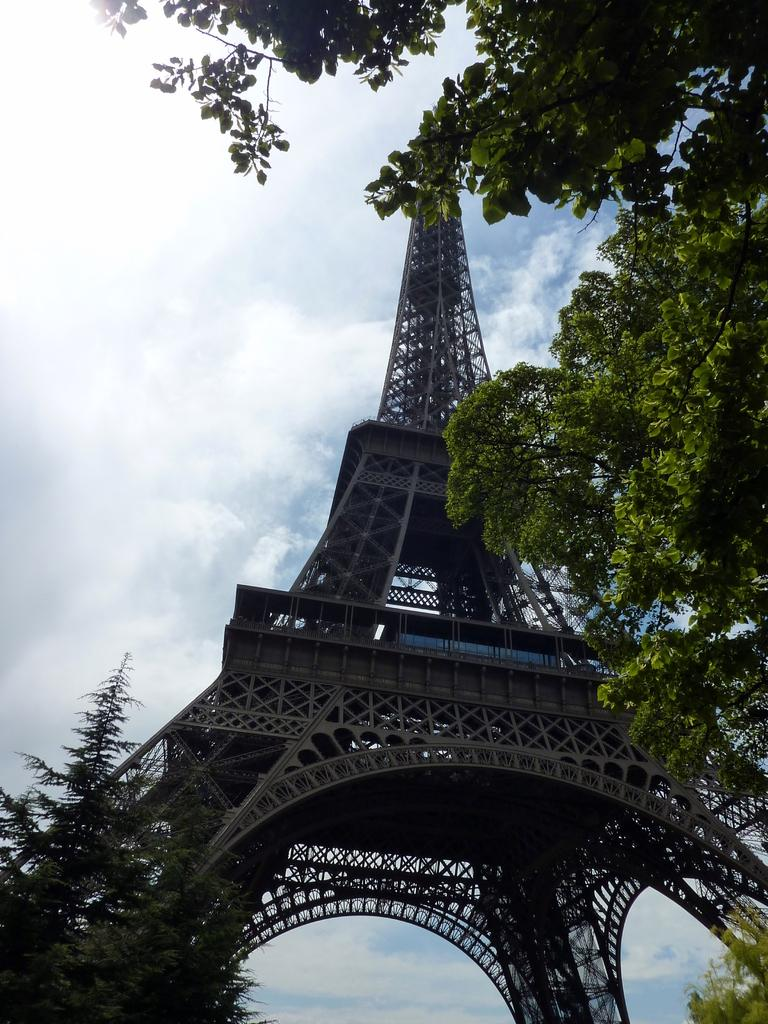What famous landmark can be seen in the image? The Eiffel Tower is visible in the image. What type of vegetation is present in the image? There are branches of trees in the image. What can be seen in the background of the image? The sky is visible in the background of the image. What is the condition of the sky in the image? Clouds are present in the sky. What type of apparel is the porter wearing in the image? There is no porter present in the image, so it is not possible to determine what type of apparel they might be wearing. 